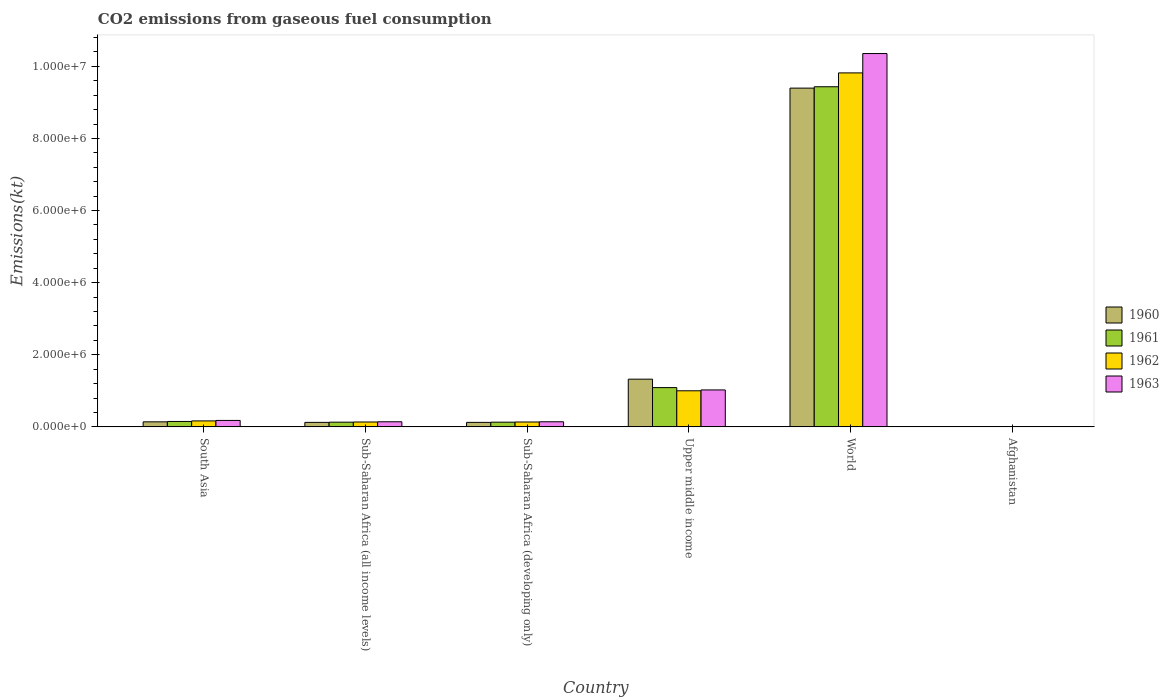Are the number of bars per tick equal to the number of legend labels?
Ensure brevity in your answer.  Yes. What is the label of the 6th group of bars from the left?
Ensure brevity in your answer.  Afghanistan. In how many cases, is the number of bars for a given country not equal to the number of legend labels?
Your response must be concise. 0. What is the amount of CO2 emitted in 1960 in South Asia?
Provide a succinct answer. 1.39e+05. Across all countries, what is the maximum amount of CO2 emitted in 1961?
Ensure brevity in your answer.  9.43e+06. Across all countries, what is the minimum amount of CO2 emitted in 1963?
Give a very brief answer. 707.73. In which country was the amount of CO2 emitted in 1961 minimum?
Keep it short and to the point. Afghanistan. What is the total amount of CO2 emitted in 1960 in the graph?
Your answer should be compact. 1.11e+07. What is the difference between the amount of CO2 emitted in 1961 in Afghanistan and that in Sub-Saharan Africa (developing only)?
Provide a short and direct response. -1.30e+05. What is the difference between the amount of CO2 emitted in 1963 in World and the amount of CO2 emitted in 1960 in South Asia?
Your response must be concise. 1.02e+07. What is the average amount of CO2 emitted in 1962 per country?
Give a very brief answer. 1.88e+06. What is the difference between the amount of CO2 emitted of/in 1960 and amount of CO2 emitted of/in 1961 in World?
Your answer should be very brief. -3.77e+04. In how many countries, is the amount of CO2 emitted in 1960 greater than 8000000 kt?
Your answer should be very brief. 1. What is the ratio of the amount of CO2 emitted in 1961 in South Asia to that in World?
Offer a very short reply. 0.02. What is the difference between the highest and the second highest amount of CO2 emitted in 1960?
Your answer should be very brief. 9.26e+06. What is the difference between the highest and the lowest amount of CO2 emitted in 1962?
Your response must be concise. 9.82e+06. Is it the case that in every country, the sum of the amount of CO2 emitted in 1963 and amount of CO2 emitted in 1961 is greater than the sum of amount of CO2 emitted in 1962 and amount of CO2 emitted in 1960?
Your answer should be compact. No. What does the 2nd bar from the right in Sub-Saharan Africa (all income levels) represents?
Give a very brief answer. 1962. Are all the bars in the graph horizontal?
Keep it short and to the point. No. How many legend labels are there?
Provide a succinct answer. 4. How are the legend labels stacked?
Your answer should be very brief. Vertical. What is the title of the graph?
Keep it short and to the point. CO2 emissions from gaseous fuel consumption. Does "1996" appear as one of the legend labels in the graph?
Your response must be concise. No. What is the label or title of the X-axis?
Provide a succinct answer. Country. What is the label or title of the Y-axis?
Make the answer very short. Emissions(kt). What is the Emissions(kt) in 1960 in South Asia?
Ensure brevity in your answer.  1.39e+05. What is the Emissions(kt) in 1961 in South Asia?
Offer a terse response. 1.50e+05. What is the Emissions(kt) of 1962 in South Asia?
Make the answer very short. 1.65e+05. What is the Emissions(kt) of 1963 in South Asia?
Provide a succinct answer. 1.78e+05. What is the Emissions(kt) of 1960 in Sub-Saharan Africa (all income levels)?
Offer a terse response. 1.25e+05. What is the Emissions(kt) in 1961 in Sub-Saharan Africa (all income levels)?
Your response must be concise. 1.30e+05. What is the Emissions(kt) in 1962 in Sub-Saharan Africa (all income levels)?
Keep it short and to the point. 1.35e+05. What is the Emissions(kt) of 1963 in Sub-Saharan Africa (all income levels)?
Offer a terse response. 1.41e+05. What is the Emissions(kt) of 1960 in Sub-Saharan Africa (developing only)?
Offer a terse response. 1.24e+05. What is the Emissions(kt) of 1961 in Sub-Saharan Africa (developing only)?
Your answer should be very brief. 1.30e+05. What is the Emissions(kt) of 1962 in Sub-Saharan Africa (developing only)?
Your answer should be compact. 1.35e+05. What is the Emissions(kt) of 1963 in Sub-Saharan Africa (developing only)?
Your answer should be very brief. 1.41e+05. What is the Emissions(kt) of 1960 in Upper middle income?
Provide a succinct answer. 1.32e+06. What is the Emissions(kt) of 1961 in Upper middle income?
Your response must be concise. 1.09e+06. What is the Emissions(kt) of 1962 in Upper middle income?
Keep it short and to the point. 1.00e+06. What is the Emissions(kt) in 1963 in Upper middle income?
Your answer should be very brief. 1.02e+06. What is the Emissions(kt) in 1960 in World?
Ensure brevity in your answer.  9.40e+06. What is the Emissions(kt) of 1961 in World?
Provide a succinct answer. 9.43e+06. What is the Emissions(kt) in 1962 in World?
Offer a very short reply. 9.82e+06. What is the Emissions(kt) of 1963 in World?
Keep it short and to the point. 1.04e+07. What is the Emissions(kt) in 1960 in Afghanistan?
Make the answer very short. 414.37. What is the Emissions(kt) in 1961 in Afghanistan?
Provide a short and direct response. 491.38. What is the Emissions(kt) in 1962 in Afghanistan?
Keep it short and to the point. 689.4. What is the Emissions(kt) in 1963 in Afghanistan?
Ensure brevity in your answer.  707.73. Across all countries, what is the maximum Emissions(kt) of 1960?
Your response must be concise. 9.40e+06. Across all countries, what is the maximum Emissions(kt) in 1961?
Offer a terse response. 9.43e+06. Across all countries, what is the maximum Emissions(kt) in 1962?
Your answer should be compact. 9.82e+06. Across all countries, what is the maximum Emissions(kt) of 1963?
Your response must be concise. 1.04e+07. Across all countries, what is the minimum Emissions(kt) of 1960?
Make the answer very short. 414.37. Across all countries, what is the minimum Emissions(kt) in 1961?
Give a very brief answer. 491.38. Across all countries, what is the minimum Emissions(kt) of 1962?
Ensure brevity in your answer.  689.4. Across all countries, what is the minimum Emissions(kt) of 1963?
Your answer should be very brief. 707.73. What is the total Emissions(kt) of 1960 in the graph?
Your answer should be very brief. 1.11e+07. What is the total Emissions(kt) in 1961 in the graph?
Offer a very short reply. 1.09e+07. What is the total Emissions(kt) in 1962 in the graph?
Ensure brevity in your answer.  1.13e+07. What is the total Emissions(kt) in 1963 in the graph?
Your answer should be very brief. 1.18e+07. What is the difference between the Emissions(kt) of 1960 in South Asia and that in Sub-Saharan Africa (all income levels)?
Offer a very short reply. 1.50e+04. What is the difference between the Emissions(kt) of 1961 in South Asia and that in Sub-Saharan Africa (all income levels)?
Ensure brevity in your answer.  1.99e+04. What is the difference between the Emissions(kt) in 1962 in South Asia and that in Sub-Saharan Africa (all income levels)?
Make the answer very short. 3.05e+04. What is the difference between the Emissions(kt) of 1963 in South Asia and that in Sub-Saharan Africa (all income levels)?
Give a very brief answer. 3.72e+04. What is the difference between the Emissions(kt) in 1960 in South Asia and that in Sub-Saharan Africa (developing only)?
Offer a terse response. 1.50e+04. What is the difference between the Emissions(kt) in 1961 in South Asia and that in Sub-Saharan Africa (developing only)?
Offer a terse response. 1.99e+04. What is the difference between the Emissions(kt) in 1962 in South Asia and that in Sub-Saharan Africa (developing only)?
Provide a succinct answer. 3.05e+04. What is the difference between the Emissions(kt) in 1963 in South Asia and that in Sub-Saharan Africa (developing only)?
Your answer should be very brief. 3.72e+04. What is the difference between the Emissions(kt) in 1960 in South Asia and that in Upper middle income?
Offer a very short reply. -1.18e+06. What is the difference between the Emissions(kt) in 1961 in South Asia and that in Upper middle income?
Provide a succinct answer. -9.39e+05. What is the difference between the Emissions(kt) in 1962 in South Asia and that in Upper middle income?
Provide a succinct answer. -8.36e+05. What is the difference between the Emissions(kt) in 1963 in South Asia and that in Upper middle income?
Ensure brevity in your answer.  -8.46e+05. What is the difference between the Emissions(kt) of 1960 in South Asia and that in World?
Your answer should be compact. -9.26e+06. What is the difference between the Emissions(kt) in 1961 in South Asia and that in World?
Offer a very short reply. -9.28e+06. What is the difference between the Emissions(kt) of 1962 in South Asia and that in World?
Your answer should be very brief. -9.65e+06. What is the difference between the Emissions(kt) of 1963 in South Asia and that in World?
Your answer should be compact. -1.02e+07. What is the difference between the Emissions(kt) in 1960 in South Asia and that in Afghanistan?
Give a very brief answer. 1.39e+05. What is the difference between the Emissions(kt) in 1961 in South Asia and that in Afghanistan?
Provide a succinct answer. 1.50e+05. What is the difference between the Emissions(kt) of 1962 in South Asia and that in Afghanistan?
Provide a succinct answer. 1.65e+05. What is the difference between the Emissions(kt) of 1963 in South Asia and that in Afghanistan?
Give a very brief answer. 1.78e+05. What is the difference between the Emissions(kt) in 1960 in Sub-Saharan Africa (all income levels) and that in Sub-Saharan Africa (developing only)?
Your answer should be compact. 25.95. What is the difference between the Emissions(kt) of 1961 in Sub-Saharan Africa (all income levels) and that in Sub-Saharan Africa (developing only)?
Provide a short and direct response. 26.08. What is the difference between the Emissions(kt) in 1962 in Sub-Saharan Africa (all income levels) and that in Sub-Saharan Africa (developing only)?
Make the answer very short. 26.17. What is the difference between the Emissions(kt) of 1963 in Sub-Saharan Africa (all income levels) and that in Sub-Saharan Africa (developing only)?
Make the answer very short. 30.19. What is the difference between the Emissions(kt) in 1960 in Sub-Saharan Africa (all income levels) and that in Upper middle income?
Offer a very short reply. -1.20e+06. What is the difference between the Emissions(kt) in 1961 in Sub-Saharan Africa (all income levels) and that in Upper middle income?
Offer a terse response. -9.59e+05. What is the difference between the Emissions(kt) in 1962 in Sub-Saharan Africa (all income levels) and that in Upper middle income?
Make the answer very short. -8.66e+05. What is the difference between the Emissions(kt) of 1963 in Sub-Saharan Africa (all income levels) and that in Upper middle income?
Your answer should be compact. -8.83e+05. What is the difference between the Emissions(kt) of 1960 in Sub-Saharan Africa (all income levels) and that in World?
Ensure brevity in your answer.  -9.27e+06. What is the difference between the Emissions(kt) of 1961 in Sub-Saharan Africa (all income levels) and that in World?
Give a very brief answer. -9.30e+06. What is the difference between the Emissions(kt) of 1962 in Sub-Saharan Africa (all income levels) and that in World?
Your answer should be compact. -9.68e+06. What is the difference between the Emissions(kt) of 1963 in Sub-Saharan Africa (all income levels) and that in World?
Offer a very short reply. -1.02e+07. What is the difference between the Emissions(kt) in 1960 in Sub-Saharan Africa (all income levels) and that in Afghanistan?
Make the answer very short. 1.24e+05. What is the difference between the Emissions(kt) of 1961 in Sub-Saharan Africa (all income levels) and that in Afghanistan?
Offer a terse response. 1.30e+05. What is the difference between the Emissions(kt) in 1962 in Sub-Saharan Africa (all income levels) and that in Afghanistan?
Provide a succinct answer. 1.34e+05. What is the difference between the Emissions(kt) of 1963 in Sub-Saharan Africa (all income levels) and that in Afghanistan?
Provide a short and direct response. 1.41e+05. What is the difference between the Emissions(kt) in 1960 in Sub-Saharan Africa (developing only) and that in Upper middle income?
Give a very brief answer. -1.20e+06. What is the difference between the Emissions(kt) of 1961 in Sub-Saharan Africa (developing only) and that in Upper middle income?
Your response must be concise. -9.59e+05. What is the difference between the Emissions(kt) of 1962 in Sub-Saharan Africa (developing only) and that in Upper middle income?
Make the answer very short. -8.66e+05. What is the difference between the Emissions(kt) of 1963 in Sub-Saharan Africa (developing only) and that in Upper middle income?
Your answer should be very brief. -8.83e+05. What is the difference between the Emissions(kt) in 1960 in Sub-Saharan Africa (developing only) and that in World?
Offer a terse response. -9.27e+06. What is the difference between the Emissions(kt) in 1961 in Sub-Saharan Africa (developing only) and that in World?
Your answer should be compact. -9.30e+06. What is the difference between the Emissions(kt) in 1962 in Sub-Saharan Africa (developing only) and that in World?
Offer a very short reply. -9.68e+06. What is the difference between the Emissions(kt) in 1963 in Sub-Saharan Africa (developing only) and that in World?
Provide a short and direct response. -1.02e+07. What is the difference between the Emissions(kt) in 1960 in Sub-Saharan Africa (developing only) and that in Afghanistan?
Keep it short and to the point. 1.24e+05. What is the difference between the Emissions(kt) of 1961 in Sub-Saharan Africa (developing only) and that in Afghanistan?
Make the answer very short. 1.30e+05. What is the difference between the Emissions(kt) in 1962 in Sub-Saharan Africa (developing only) and that in Afghanistan?
Your answer should be compact. 1.34e+05. What is the difference between the Emissions(kt) in 1963 in Sub-Saharan Africa (developing only) and that in Afghanistan?
Provide a short and direct response. 1.41e+05. What is the difference between the Emissions(kt) of 1960 in Upper middle income and that in World?
Give a very brief answer. -8.07e+06. What is the difference between the Emissions(kt) in 1961 in Upper middle income and that in World?
Your answer should be compact. -8.35e+06. What is the difference between the Emissions(kt) in 1962 in Upper middle income and that in World?
Your answer should be very brief. -8.82e+06. What is the difference between the Emissions(kt) of 1963 in Upper middle income and that in World?
Offer a terse response. -9.33e+06. What is the difference between the Emissions(kt) of 1960 in Upper middle income and that in Afghanistan?
Offer a very short reply. 1.32e+06. What is the difference between the Emissions(kt) of 1961 in Upper middle income and that in Afghanistan?
Offer a very short reply. 1.09e+06. What is the difference between the Emissions(kt) in 1962 in Upper middle income and that in Afghanistan?
Your answer should be very brief. 1.00e+06. What is the difference between the Emissions(kt) of 1963 in Upper middle income and that in Afghanistan?
Offer a terse response. 1.02e+06. What is the difference between the Emissions(kt) of 1960 in World and that in Afghanistan?
Your answer should be compact. 9.40e+06. What is the difference between the Emissions(kt) of 1961 in World and that in Afghanistan?
Your answer should be compact. 9.43e+06. What is the difference between the Emissions(kt) in 1962 in World and that in Afghanistan?
Your response must be concise. 9.82e+06. What is the difference between the Emissions(kt) in 1963 in World and that in Afghanistan?
Provide a succinct answer. 1.04e+07. What is the difference between the Emissions(kt) in 1960 in South Asia and the Emissions(kt) in 1961 in Sub-Saharan Africa (all income levels)?
Give a very brief answer. 9266.84. What is the difference between the Emissions(kt) of 1960 in South Asia and the Emissions(kt) of 1962 in Sub-Saharan Africa (all income levels)?
Ensure brevity in your answer.  4699.93. What is the difference between the Emissions(kt) in 1960 in South Asia and the Emissions(kt) in 1963 in Sub-Saharan Africa (all income levels)?
Ensure brevity in your answer.  -1820.31. What is the difference between the Emissions(kt) of 1961 in South Asia and the Emissions(kt) of 1962 in Sub-Saharan Africa (all income levels)?
Your response must be concise. 1.53e+04. What is the difference between the Emissions(kt) in 1961 in South Asia and the Emissions(kt) in 1963 in Sub-Saharan Africa (all income levels)?
Make the answer very short. 8808.5. What is the difference between the Emissions(kt) in 1962 in South Asia and the Emissions(kt) in 1963 in Sub-Saharan Africa (all income levels)?
Provide a short and direct response. 2.40e+04. What is the difference between the Emissions(kt) of 1960 in South Asia and the Emissions(kt) of 1961 in Sub-Saharan Africa (developing only)?
Offer a terse response. 9292.91. What is the difference between the Emissions(kt) in 1960 in South Asia and the Emissions(kt) in 1962 in Sub-Saharan Africa (developing only)?
Ensure brevity in your answer.  4726.11. What is the difference between the Emissions(kt) in 1960 in South Asia and the Emissions(kt) in 1963 in Sub-Saharan Africa (developing only)?
Offer a very short reply. -1790.11. What is the difference between the Emissions(kt) in 1961 in South Asia and the Emissions(kt) in 1962 in Sub-Saharan Africa (developing only)?
Offer a very short reply. 1.54e+04. What is the difference between the Emissions(kt) of 1961 in South Asia and the Emissions(kt) of 1963 in Sub-Saharan Africa (developing only)?
Ensure brevity in your answer.  8838.69. What is the difference between the Emissions(kt) of 1962 in South Asia and the Emissions(kt) of 1963 in Sub-Saharan Africa (developing only)?
Offer a terse response. 2.40e+04. What is the difference between the Emissions(kt) in 1960 in South Asia and the Emissions(kt) in 1961 in Upper middle income?
Make the answer very short. -9.50e+05. What is the difference between the Emissions(kt) of 1960 in South Asia and the Emissions(kt) of 1962 in Upper middle income?
Ensure brevity in your answer.  -8.61e+05. What is the difference between the Emissions(kt) in 1960 in South Asia and the Emissions(kt) in 1963 in Upper middle income?
Give a very brief answer. -8.85e+05. What is the difference between the Emissions(kt) of 1961 in South Asia and the Emissions(kt) of 1962 in Upper middle income?
Make the answer very short. -8.51e+05. What is the difference between the Emissions(kt) of 1961 in South Asia and the Emissions(kt) of 1963 in Upper middle income?
Keep it short and to the point. -8.75e+05. What is the difference between the Emissions(kt) of 1962 in South Asia and the Emissions(kt) of 1963 in Upper middle income?
Your answer should be compact. -8.59e+05. What is the difference between the Emissions(kt) of 1960 in South Asia and the Emissions(kt) of 1961 in World?
Provide a succinct answer. -9.29e+06. What is the difference between the Emissions(kt) of 1960 in South Asia and the Emissions(kt) of 1962 in World?
Provide a short and direct response. -9.68e+06. What is the difference between the Emissions(kt) in 1960 in South Asia and the Emissions(kt) in 1963 in World?
Make the answer very short. -1.02e+07. What is the difference between the Emissions(kt) of 1961 in South Asia and the Emissions(kt) of 1962 in World?
Make the answer very short. -9.67e+06. What is the difference between the Emissions(kt) of 1961 in South Asia and the Emissions(kt) of 1963 in World?
Your response must be concise. -1.02e+07. What is the difference between the Emissions(kt) in 1962 in South Asia and the Emissions(kt) in 1963 in World?
Offer a very short reply. -1.02e+07. What is the difference between the Emissions(kt) of 1960 in South Asia and the Emissions(kt) of 1961 in Afghanistan?
Offer a terse response. 1.39e+05. What is the difference between the Emissions(kt) in 1960 in South Asia and the Emissions(kt) in 1962 in Afghanistan?
Provide a short and direct response. 1.39e+05. What is the difference between the Emissions(kt) in 1960 in South Asia and the Emissions(kt) in 1963 in Afghanistan?
Provide a succinct answer. 1.39e+05. What is the difference between the Emissions(kt) in 1961 in South Asia and the Emissions(kt) in 1962 in Afghanistan?
Ensure brevity in your answer.  1.49e+05. What is the difference between the Emissions(kt) of 1961 in South Asia and the Emissions(kt) of 1963 in Afghanistan?
Your answer should be compact. 1.49e+05. What is the difference between the Emissions(kt) of 1962 in South Asia and the Emissions(kt) of 1963 in Afghanistan?
Offer a terse response. 1.65e+05. What is the difference between the Emissions(kt) of 1960 in Sub-Saharan Africa (all income levels) and the Emissions(kt) of 1961 in Sub-Saharan Africa (developing only)?
Offer a very short reply. -5693.06. What is the difference between the Emissions(kt) in 1960 in Sub-Saharan Africa (all income levels) and the Emissions(kt) in 1962 in Sub-Saharan Africa (developing only)?
Make the answer very short. -1.03e+04. What is the difference between the Emissions(kt) of 1960 in Sub-Saharan Africa (all income levels) and the Emissions(kt) of 1963 in Sub-Saharan Africa (developing only)?
Give a very brief answer. -1.68e+04. What is the difference between the Emissions(kt) of 1961 in Sub-Saharan Africa (all income levels) and the Emissions(kt) of 1962 in Sub-Saharan Africa (developing only)?
Offer a terse response. -4540.73. What is the difference between the Emissions(kt) of 1961 in Sub-Saharan Africa (all income levels) and the Emissions(kt) of 1963 in Sub-Saharan Africa (developing only)?
Keep it short and to the point. -1.11e+04. What is the difference between the Emissions(kt) of 1962 in Sub-Saharan Africa (all income levels) and the Emissions(kt) of 1963 in Sub-Saharan Africa (developing only)?
Make the answer very short. -6490.04. What is the difference between the Emissions(kt) in 1960 in Sub-Saharan Africa (all income levels) and the Emissions(kt) in 1961 in Upper middle income?
Provide a short and direct response. -9.65e+05. What is the difference between the Emissions(kt) in 1960 in Sub-Saharan Africa (all income levels) and the Emissions(kt) in 1962 in Upper middle income?
Keep it short and to the point. -8.76e+05. What is the difference between the Emissions(kt) of 1960 in Sub-Saharan Africa (all income levels) and the Emissions(kt) of 1963 in Upper middle income?
Offer a terse response. -9.00e+05. What is the difference between the Emissions(kt) in 1961 in Sub-Saharan Africa (all income levels) and the Emissions(kt) in 1962 in Upper middle income?
Give a very brief answer. -8.71e+05. What is the difference between the Emissions(kt) in 1961 in Sub-Saharan Africa (all income levels) and the Emissions(kt) in 1963 in Upper middle income?
Offer a very short reply. -8.94e+05. What is the difference between the Emissions(kt) of 1962 in Sub-Saharan Africa (all income levels) and the Emissions(kt) of 1963 in Upper middle income?
Keep it short and to the point. -8.90e+05. What is the difference between the Emissions(kt) of 1960 in Sub-Saharan Africa (all income levels) and the Emissions(kt) of 1961 in World?
Offer a terse response. -9.31e+06. What is the difference between the Emissions(kt) of 1960 in Sub-Saharan Africa (all income levels) and the Emissions(kt) of 1962 in World?
Offer a terse response. -9.69e+06. What is the difference between the Emissions(kt) in 1960 in Sub-Saharan Africa (all income levels) and the Emissions(kt) in 1963 in World?
Your response must be concise. -1.02e+07. What is the difference between the Emissions(kt) in 1961 in Sub-Saharan Africa (all income levels) and the Emissions(kt) in 1962 in World?
Your answer should be very brief. -9.69e+06. What is the difference between the Emissions(kt) of 1961 in Sub-Saharan Africa (all income levels) and the Emissions(kt) of 1963 in World?
Provide a short and direct response. -1.02e+07. What is the difference between the Emissions(kt) of 1962 in Sub-Saharan Africa (all income levels) and the Emissions(kt) of 1963 in World?
Provide a succinct answer. -1.02e+07. What is the difference between the Emissions(kt) of 1960 in Sub-Saharan Africa (all income levels) and the Emissions(kt) of 1961 in Afghanistan?
Your answer should be compact. 1.24e+05. What is the difference between the Emissions(kt) of 1960 in Sub-Saharan Africa (all income levels) and the Emissions(kt) of 1962 in Afghanistan?
Make the answer very short. 1.24e+05. What is the difference between the Emissions(kt) of 1960 in Sub-Saharan Africa (all income levels) and the Emissions(kt) of 1963 in Afghanistan?
Your answer should be compact. 1.24e+05. What is the difference between the Emissions(kt) of 1961 in Sub-Saharan Africa (all income levels) and the Emissions(kt) of 1962 in Afghanistan?
Offer a very short reply. 1.30e+05. What is the difference between the Emissions(kt) of 1961 in Sub-Saharan Africa (all income levels) and the Emissions(kt) of 1963 in Afghanistan?
Provide a succinct answer. 1.30e+05. What is the difference between the Emissions(kt) in 1962 in Sub-Saharan Africa (all income levels) and the Emissions(kt) in 1963 in Afghanistan?
Your answer should be very brief. 1.34e+05. What is the difference between the Emissions(kt) in 1960 in Sub-Saharan Africa (developing only) and the Emissions(kt) in 1961 in Upper middle income?
Ensure brevity in your answer.  -9.65e+05. What is the difference between the Emissions(kt) in 1960 in Sub-Saharan Africa (developing only) and the Emissions(kt) in 1962 in Upper middle income?
Make the answer very short. -8.76e+05. What is the difference between the Emissions(kt) in 1960 in Sub-Saharan Africa (developing only) and the Emissions(kt) in 1963 in Upper middle income?
Your answer should be very brief. -9.00e+05. What is the difference between the Emissions(kt) in 1961 in Sub-Saharan Africa (developing only) and the Emissions(kt) in 1962 in Upper middle income?
Your answer should be very brief. -8.71e+05. What is the difference between the Emissions(kt) in 1961 in Sub-Saharan Africa (developing only) and the Emissions(kt) in 1963 in Upper middle income?
Provide a short and direct response. -8.94e+05. What is the difference between the Emissions(kt) of 1962 in Sub-Saharan Africa (developing only) and the Emissions(kt) of 1963 in Upper middle income?
Provide a succinct answer. -8.90e+05. What is the difference between the Emissions(kt) of 1960 in Sub-Saharan Africa (developing only) and the Emissions(kt) of 1961 in World?
Your response must be concise. -9.31e+06. What is the difference between the Emissions(kt) of 1960 in Sub-Saharan Africa (developing only) and the Emissions(kt) of 1962 in World?
Your answer should be very brief. -9.69e+06. What is the difference between the Emissions(kt) in 1960 in Sub-Saharan Africa (developing only) and the Emissions(kt) in 1963 in World?
Offer a very short reply. -1.02e+07. What is the difference between the Emissions(kt) in 1961 in Sub-Saharan Africa (developing only) and the Emissions(kt) in 1962 in World?
Make the answer very short. -9.69e+06. What is the difference between the Emissions(kt) in 1961 in Sub-Saharan Africa (developing only) and the Emissions(kt) in 1963 in World?
Keep it short and to the point. -1.02e+07. What is the difference between the Emissions(kt) in 1962 in Sub-Saharan Africa (developing only) and the Emissions(kt) in 1963 in World?
Make the answer very short. -1.02e+07. What is the difference between the Emissions(kt) of 1960 in Sub-Saharan Africa (developing only) and the Emissions(kt) of 1961 in Afghanistan?
Offer a terse response. 1.24e+05. What is the difference between the Emissions(kt) of 1960 in Sub-Saharan Africa (developing only) and the Emissions(kt) of 1962 in Afghanistan?
Make the answer very short. 1.24e+05. What is the difference between the Emissions(kt) in 1960 in Sub-Saharan Africa (developing only) and the Emissions(kt) in 1963 in Afghanistan?
Give a very brief answer. 1.24e+05. What is the difference between the Emissions(kt) in 1961 in Sub-Saharan Africa (developing only) and the Emissions(kt) in 1962 in Afghanistan?
Offer a terse response. 1.30e+05. What is the difference between the Emissions(kt) in 1961 in Sub-Saharan Africa (developing only) and the Emissions(kt) in 1963 in Afghanistan?
Ensure brevity in your answer.  1.29e+05. What is the difference between the Emissions(kt) of 1962 in Sub-Saharan Africa (developing only) and the Emissions(kt) of 1963 in Afghanistan?
Your answer should be very brief. 1.34e+05. What is the difference between the Emissions(kt) in 1960 in Upper middle income and the Emissions(kt) in 1961 in World?
Keep it short and to the point. -8.11e+06. What is the difference between the Emissions(kt) of 1960 in Upper middle income and the Emissions(kt) of 1962 in World?
Provide a short and direct response. -8.50e+06. What is the difference between the Emissions(kt) in 1960 in Upper middle income and the Emissions(kt) in 1963 in World?
Offer a terse response. -9.03e+06. What is the difference between the Emissions(kt) in 1961 in Upper middle income and the Emissions(kt) in 1962 in World?
Make the answer very short. -8.73e+06. What is the difference between the Emissions(kt) of 1961 in Upper middle income and the Emissions(kt) of 1963 in World?
Offer a very short reply. -9.27e+06. What is the difference between the Emissions(kt) of 1962 in Upper middle income and the Emissions(kt) of 1963 in World?
Provide a succinct answer. -9.35e+06. What is the difference between the Emissions(kt) of 1960 in Upper middle income and the Emissions(kt) of 1961 in Afghanistan?
Provide a succinct answer. 1.32e+06. What is the difference between the Emissions(kt) in 1960 in Upper middle income and the Emissions(kt) in 1962 in Afghanistan?
Your response must be concise. 1.32e+06. What is the difference between the Emissions(kt) in 1960 in Upper middle income and the Emissions(kt) in 1963 in Afghanistan?
Give a very brief answer. 1.32e+06. What is the difference between the Emissions(kt) in 1961 in Upper middle income and the Emissions(kt) in 1962 in Afghanistan?
Your answer should be very brief. 1.09e+06. What is the difference between the Emissions(kt) of 1961 in Upper middle income and the Emissions(kt) of 1963 in Afghanistan?
Your answer should be compact. 1.09e+06. What is the difference between the Emissions(kt) in 1962 in Upper middle income and the Emissions(kt) in 1963 in Afghanistan?
Provide a short and direct response. 1.00e+06. What is the difference between the Emissions(kt) in 1960 in World and the Emissions(kt) in 1961 in Afghanistan?
Your answer should be very brief. 9.40e+06. What is the difference between the Emissions(kt) of 1960 in World and the Emissions(kt) of 1962 in Afghanistan?
Your answer should be compact. 9.40e+06. What is the difference between the Emissions(kt) in 1960 in World and the Emissions(kt) in 1963 in Afghanistan?
Offer a very short reply. 9.40e+06. What is the difference between the Emissions(kt) in 1961 in World and the Emissions(kt) in 1962 in Afghanistan?
Provide a short and direct response. 9.43e+06. What is the difference between the Emissions(kt) in 1961 in World and the Emissions(kt) in 1963 in Afghanistan?
Your response must be concise. 9.43e+06. What is the difference between the Emissions(kt) in 1962 in World and the Emissions(kt) in 1963 in Afghanistan?
Your response must be concise. 9.82e+06. What is the average Emissions(kt) of 1960 per country?
Your answer should be compact. 1.85e+06. What is the average Emissions(kt) of 1961 per country?
Your response must be concise. 1.82e+06. What is the average Emissions(kt) of 1962 per country?
Offer a very short reply. 1.88e+06. What is the average Emissions(kt) of 1963 per country?
Your answer should be compact. 1.97e+06. What is the difference between the Emissions(kt) in 1960 and Emissions(kt) in 1961 in South Asia?
Offer a terse response. -1.06e+04. What is the difference between the Emissions(kt) of 1960 and Emissions(kt) of 1962 in South Asia?
Offer a very short reply. -2.58e+04. What is the difference between the Emissions(kt) in 1960 and Emissions(kt) in 1963 in South Asia?
Offer a terse response. -3.90e+04. What is the difference between the Emissions(kt) in 1961 and Emissions(kt) in 1962 in South Asia?
Keep it short and to the point. -1.52e+04. What is the difference between the Emissions(kt) in 1961 and Emissions(kt) in 1963 in South Asia?
Provide a succinct answer. -2.84e+04. What is the difference between the Emissions(kt) of 1962 and Emissions(kt) of 1963 in South Asia?
Your answer should be compact. -1.32e+04. What is the difference between the Emissions(kt) of 1960 and Emissions(kt) of 1961 in Sub-Saharan Africa (all income levels)?
Ensure brevity in your answer.  -5719.13. What is the difference between the Emissions(kt) in 1960 and Emissions(kt) in 1962 in Sub-Saharan Africa (all income levels)?
Make the answer very short. -1.03e+04. What is the difference between the Emissions(kt) in 1960 and Emissions(kt) in 1963 in Sub-Saharan Africa (all income levels)?
Provide a succinct answer. -1.68e+04. What is the difference between the Emissions(kt) in 1961 and Emissions(kt) in 1962 in Sub-Saharan Africa (all income levels)?
Make the answer very short. -4566.91. What is the difference between the Emissions(kt) in 1961 and Emissions(kt) in 1963 in Sub-Saharan Africa (all income levels)?
Provide a short and direct response. -1.11e+04. What is the difference between the Emissions(kt) of 1962 and Emissions(kt) of 1963 in Sub-Saharan Africa (all income levels)?
Keep it short and to the point. -6520.24. What is the difference between the Emissions(kt) of 1960 and Emissions(kt) of 1961 in Sub-Saharan Africa (developing only)?
Your answer should be compact. -5719.01. What is the difference between the Emissions(kt) of 1960 and Emissions(kt) of 1962 in Sub-Saharan Africa (developing only)?
Your answer should be very brief. -1.03e+04. What is the difference between the Emissions(kt) in 1960 and Emissions(kt) in 1963 in Sub-Saharan Africa (developing only)?
Make the answer very short. -1.68e+04. What is the difference between the Emissions(kt) of 1961 and Emissions(kt) of 1962 in Sub-Saharan Africa (developing only)?
Your answer should be compact. -4566.81. What is the difference between the Emissions(kt) of 1961 and Emissions(kt) of 1963 in Sub-Saharan Africa (developing only)?
Your answer should be very brief. -1.11e+04. What is the difference between the Emissions(kt) of 1962 and Emissions(kt) of 1963 in Sub-Saharan Africa (developing only)?
Your answer should be very brief. -6516.22. What is the difference between the Emissions(kt) in 1960 and Emissions(kt) in 1961 in Upper middle income?
Ensure brevity in your answer.  2.34e+05. What is the difference between the Emissions(kt) in 1960 and Emissions(kt) in 1962 in Upper middle income?
Ensure brevity in your answer.  3.23e+05. What is the difference between the Emissions(kt) of 1960 and Emissions(kt) of 1963 in Upper middle income?
Your response must be concise. 2.99e+05. What is the difference between the Emissions(kt) of 1961 and Emissions(kt) of 1962 in Upper middle income?
Provide a succinct answer. 8.85e+04. What is the difference between the Emissions(kt) of 1961 and Emissions(kt) of 1963 in Upper middle income?
Keep it short and to the point. 6.47e+04. What is the difference between the Emissions(kt) of 1962 and Emissions(kt) of 1963 in Upper middle income?
Keep it short and to the point. -2.38e+04. What is the difference between the Emissions(kt) of 1960 and Emissions(kt) of 1961 in World?
Offer a terse response. -3.77e+04. What is the difference between the Emissions(kt) in 1960 and Emissions(kt) in 1962 in World?
Your answer should be very brief. -4.22e+05. What is the difference between the Emissions(kt) in 1960 and Emissions(kt) in 1963 in World?
Your answer should be compact. -9.59e+05. What is the difference between the Emissions(kt) in 1961 and Emissions(kt) in 1962 in World?
Provide a short and direct response. -3.84e+05. What is the difference between the Emissions(kt) of 1961 and Emissions(kt) of 1963 in World?
Offer a very short reply. -9.21e+05. What is the difference between the Emissions(kt) in 1962 and Emissions(kt) in 1963 in World?
Keep it short and to the point. -5.37e+05. What is the difference between the Emissions(kt) of 1960 and Emissions(kt) of 1961 in Afghanistan?
Ensure brevity in your answer.  -77.01. What is the difference between the Emissions(kt) of 1960 and Emissions(kt) of 1962 in Afghanistan?
Provide a short and direct response. -275.02. What is the difference between the Emissions(kt) of 1960 and Emissions(kt) of 1963 in Afghanistan?
Your answer should be compact. -293.36. What is the difference between the Emissions(kt) in 1961 and Emissions(kt) in 1962 in Afghanistan?
Make the answer very short. -198.02. What is the difference between the Emissions(kt) of 1961 and Emissions(kt) of 1963 in Afghanistan?
Your response must be concise. -216.35. What is the difference between the Emissions(kt) of 1962 and Emissions(kt) of 1963 in Afghanistan?
Provide a short and direct response. -18.34. What is the ratio of the Emissions(kt) in 1960 in South Asia to that in Sub-Saharan Africa (all income levels)?
Your answer should be very brief. 1.12. What is the ratio of the Emissions(kt) in 1961 in South Asia to that in Sub-Saharan Africa (all income levels)?
Make the answer very short. 1.15. What is the ratio of the Emissions(kt) of 1962 in South Asia to that in Sub-Saharan Africa (all income levels)?
Give a very brief answer. 1.23. What is the ratio of the Emissions(kt) of 1963 in South Asia to that in Sub-Saharan Africa (all income levels)?
Make the answer very short. 1.26. What is the ratio of the Emissions(kt) of 1960 in South Asia to that in Sub-Saharan Africa (developing only)?
Ensure brevity in your answer.  1.12. What is the ratio of the Emissions(kt) in 1961 in South Asia to that in Sub-Saharan Africa (developing only)?
Provide a succinct answer. 1.15. What is the ratio of the Emissions(kt) in 1962 in South Asia to that in Sub-Saharan Africa (developing only)?
Provide a succinct answer. 1.23. What is the ratio of the Emissions(kt) of 1963 in South Asia to that in Sub-Saharan Africa (developing only)?
Your answer should be very brief. 1.26. What is the ratio of the Emissions(kt) of 1960 in South Asia to that in Upper middle income?
Provide a short and direct response. 0.11. What is the ratio of the Emissions(kt) in 1961 in South Asia to that in Upper middle income?
Your answer should be very brief. 0.14. What is the ratio of the Emissions(kt) in 1962 in South Asia to that in Upper middle income?
Provide a short and direct response. 0.17. What is the ratio of the Emissions(kt) of 1963 in South Asia to that in Upper middle income?
Your answer should be very brief. 0.17. What is the ratio of the Emissions(kt) of 1960 in South Asia to that in World?
Ensure brevity in your answer.  0.01. What is the ratio of the Emissions(kt) in 1961 in South Asia to that in World?
Ensure brevity in your answer.  0.02. What is the ratio of the Emissions(kt) in 1962 in South Asia to that in World?
Make the answer very short. 0.02. What is the ratio of the Emissions(kt) of 1963 in South Asia to that in World?
Ensure brevity in your answer.  0.02. What is the ratio of the Emissions(kt) in 1960 in South Asia to that in Afghanistan?
Your answer should be very brief. 336.63. What is the ratio of the Emissions(kt) in 1961 in South Asia to that in Afghanistan?
Your response must be concise. 305.5. What is the ratio of the Emissions(kt) in 1962 in South Asia to that in Afghanistan?
Offer a terse response. 239.75. What is the ratio of the Emissions(kt) of 1963 in South Asia to that in Afghanistan?
Offer a terse response. 252.21. What is the ratio of the Emissions(kt) in 1960 in Sub-Saharan Africa (all income levels) to that in Sub-Saharan Africa (developing only)?
Provide a succinct answer. 1. What is the ratio of the Emissions(kt) in 1963 in Sub-Saharan Africa (all income levels) to that in Sub-Saharan Africa (developing only)?
Keep it short and to the point. 1. What is the ratio of the Emissions(kt) of 1960 in Sub-Saharan Africa (all income levels) to that in Upper middle income?
Make the answer very short. 0.09. What is the ratio of the Emissions(kt) in 1961 in Sub-Saharan Africa (all income levels) to that in Upper middle income?
Provide a succinct answer. 0.12. What is the ratio of the Emissions(kt) in 1962 in Sub-Saharan Africa (all income levels) to that in Upper middle income?
Provide a short and direct response. 0.13. What is the ratio of the Emissions(kt) in 1963 in Sub-Saharan Africa (all income levels) to that in Upper middle income?
Ensure brevity in your answer.  0.14. What is the ratio of the Emissions(kt) of 1960 in Sub-Saharan Africa (all income levels) to that in World?
Offer a very short reply. 0.01. What is the ratio of the Emissions(kt) of 1961 in Sub-Saharan Africa (all income levels) to that in World?
Your response must be concise. 0.01. What is the ratio of the Emissions(kt) in 1962 in Sub-Saharan Africa (all income levels) to that in World?
Give a very brief answer. 0.01. What is the ratio of the Emissions(kt) in 1963 in Sub-Saharan Africa (all income levels) to that in World?
Ensure brevity in your answer.  0.01. What is the ratio of the Emissions(kt) in 1960 in Sub-Saharan Africa (all income levels) to that in Afghanistan?
Your answer should be compact. 300.46. What is the ratio of the Emissions(kt) of 1961 in Sub-Saharan Africa (all income levels) to that in Afghanistan?
Give a very brief answer. 265.01. What is the ratio of the Emissions(kt) in 1962 in Sub-Saharan Africa (all income levels) to that in Afghanistan?
Your answer should be very brief. 195.52. What is the ratio of the Emissions(kt) of 1963 in Sub-Saharan Africa (all income levels) to that in Afghanistan?
Your answer should be compact. 199.66. What is the ratio of the Emissions(kt) of 1960 in Sub-Saharan Africa (developing only) to that in Upper middle income?
Give a very brief answer. 0.09. What is the ratio of the Emissions(kt) of 1961 in Sub-Saharan Africa (developing only) to that in Upper middle income?
Your response must be concise. 0.12. What is the ratio of the Emissions(kt) of 1962 in Sub-Saharan Africa (developing only) to that in Upper middle income?
Offer a terse response. 0.13. What is the ratio of the Emissions(kt) in 1963 in Sub-Saharan Africa (developing only) to that in Upper middle income?
Ensure brevity in your answer.  0.14. What is the ratio of the Emissions(kt) in 1960 in Sub-Saharan Africa (developing only) to that in World?
Provide a succinct answer. 0.01. What is the ratio of the Emissions(kt) in 1961 in Sub-Saharan Africa (developing only) to that in World?
Your answer should be compact. 0.01. What is the ratio of the Emissions(kt) in 1962 in Sub-Saharan Africa (developing only) to that in World?
Provide a succinct answer. 0.01. What is the ratio of the Emissions(kt) of 1963 in Sub-Saharan Africa (developing only) to that in World?
Make the answer very short. 0.01. What is the ratio of the Emissions(kt) in 1960 in Sub-Saharan Africa (developing only) to that in Afghanistan?
Your answer should be compact. 300.4. What is the ratio of the Emissions(kt) in 1961 in Sub-Saharan Africa (developing only) to that in Afghanistan?
Give a very brief answer. 264.96. What is the ratio of the Emissions(kt) of 1962 in Sub-Saharan Africa (developing only) to that in Afghanistan?
Ensure brevity in your answer.  195.48. What is the ratio of the Emissions(kt) of 1963 in Sub-Saharan Africa (developing only) to that in Afghanistan?
Make the answer very short. 199.62. What is the ratio of the Emissions(kt) of 1960 in Upper middle income to that in World?
Provide a succinct answer. 0.14. What is the ratio of the Emissions(kt) in 1961 in Upper middle income to that in World?
Your answer should be compact. 0.12. What is the ratio of the Emissions(kt) of 1962 in Upper middle income to that in World?
Your response must be concise. 0.1. What is the ratio of the Emissions(kt) of 1963 in Upper middle income to that in World?
Provide a short and direct response. 0.1. What is the ratio of the Emissions(kt) in 1960 in Upper middle income to that in Afghanistan?
Offer a very short reply. 3193.73. What is the ratio of the Emissions(kt) of 1961 in Upper middle income to that in Afghanistan?
Provide a succinct answer. 2216.93. What is the ratio of the Emissions(kt) of 1962 in Upper middle income to that in Afghanistan?
Offer a terse response. 1451.8. What is the ratio of the Emissions(kt) of 1963 in Upper middle income to that in Afghanistan?
Your response must be concise. 1447.78. What is the ratio of the Emissions(kt) in 1960 in World to that in Afghanistan?
Keep it short and to the point. 2.27e+04. What is the ratio of the Emissions(kt) of 1961 in World to that in Afghanistan?
Offer a terse response. 1.92e+04. What is the ratio of the Emissions(kt) in 1962 in World to that in Afghanistan?
Your answer should be very brief. 1.42e+04. What is the ratio of the Emissions(kt) in 1963 in World to that in Afghanistan?
Give a very brief answer. 1.46e+04. What is the difference between the highest and the second highest Emissions(kt) of 1960?
Offer a very short reply. 8.07e+06. What is the difference between the highest and the second highest Emissions(kt) in 1961?
Offer a very short reply. 8.35e+06. What is the difference between the highest and the second highest Emissions(kt) of 1962?
Offer a terse response. 8.82e+06. What is the difference between the highest and the second highest Emissions(kt) in 1963?
Keep it short and to the point. 9.33e+06. What is the difference between the highest and the lowest Emissions(kt) of 1960?
Give a very brief answer. 9.40e+06. What is the difference between the highest and the lowest Emissions(kt) of 1961?
Your answer should be compact. 9.43e+06. What is the difference between the highest and the lowest Emissions(kt) in 1962?
Give a very brief answer. 9.82e+06. What is the difference between the highest and the lowest Emissions(kt) of 1963?
Keep it short and to the point. 1.04e+07. 